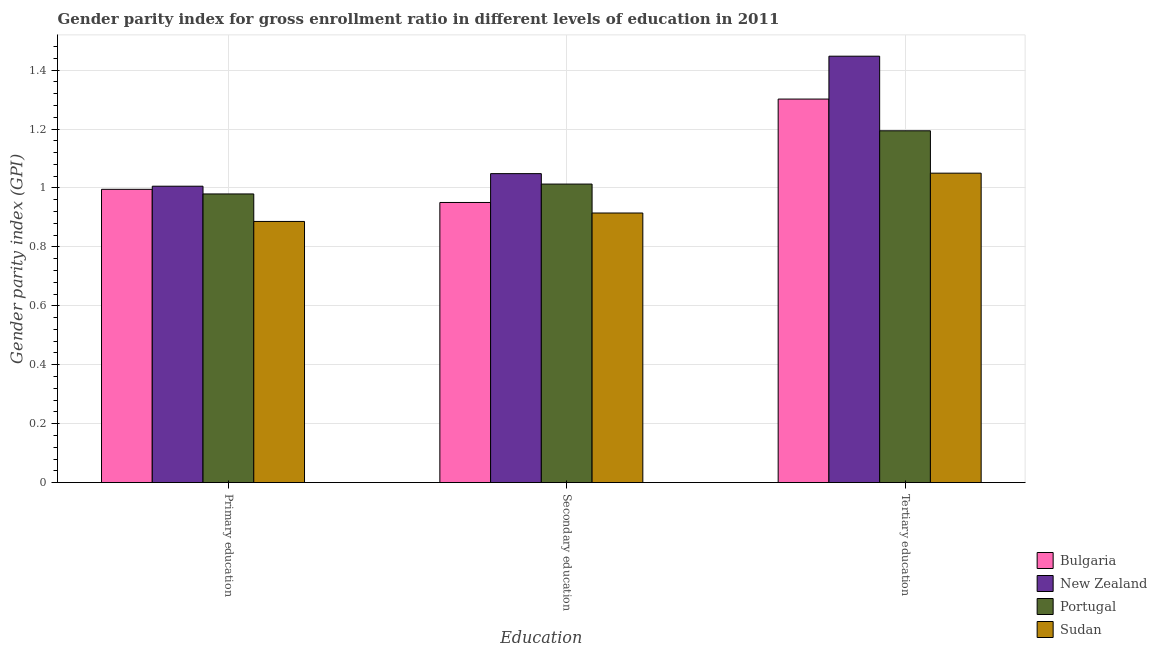How many groups of bars are there?
Your response must be concise. 3. Are the number of bars per tick equal to the number of legend labels?
Make the answer very short. Yes. What is the gender parity index in secondary education in New Zealand?
Give a very brief answer. 1.05. Across all countries, what is the maximum gender parity index in primary education?
Provide a short and direct response. 1.01. Across all countries, what is the minimum gender parity index in primary education?
Give a very brief answer. 0.89. In which country was the gender parity index in tertiary education maximum?
Your response must be concise. New Zealand. In which country was the gender parity index in tertiary education minimum?
Make the answer very short. Sudan. What is the total gender parity index in primary education in the graph?
Give a very brief answer. 3.87. What is the difference between the gender parity index in secondary education in Bulgaria and that in Portugal?
Provide a short and direct response. -0.06. What is the difference between the gender parity index in tertiary education in Bulgaria and the gender parity index in primary education in Portugal?
Keep it short and to the point. 0.32. What is the average gender parity index in tertiary education per country?
Offer a terse response. 1.25. What is the difference between the gender parity index in primary education and gender parity index in secondary education in Portugal?
Make the answer very short. -0.03. In how many countries, is the gender parity index in tertiary education greater than 0.08 ?
Offer a terse response. 4. What is the ratio of the gender parity index in tertiary education in Portugal to that in Bulgaria?
Provide a short and direct response. 0.92. Is the gender parity index in primary education in Portugal less than that in Sudan?
Your response must be concise. No. What is the difference between the highest and the second highest gender parity index in tertiary education?
Provide a short and direct response. 0.15. What is the difference between the highest and the lowest gender parity index in primary education?
Offer a very short reply. 0.12. In how many countries, is the gender parity index in tertiary education greater than the average gender parity index in tertiary education taken over all countries?
Provide a succinct answer. 2. Is the sum of the gender parity index in secondary education in Portugal and Sudan greater than the maximum gender parity index in primary education across all countries?
Offer a very short reply. Yes. What does the 2nd bar from the left in Primary education represents?
Ensure brevity in your answer.  New Zealand. What does the 2nd bar from the right in Secondary education represents?
Give a very brief answer. Portugal. Is it the case that in every country, the sum of the gender parity index in primary education and gender parity index in secondary education is greater than the gender parity index in tertiary education?
Keep it short and to the point. Yes. How many bars are there?
Ensure brevity in your answer.  12. How many countries are there in the graph?
Your answer should be very brief. 4. What is the difference between two consecutive major ticks on the Y-axis?
Provide a succinct answer. 0.2. Does the graph contain any zero values?
Make the answer very short. No. Does the graph contain grids?
Make the answer very short. Yes. How many legend labels are there?
Make the answer very short. 4. What is the title of the graph?
Give a very brief answer. Gender parity index for gross enrollment ratio in different levels of education in 2011. What is the label or title of the X-axis?
Provide a succinct answer. Education. What is the label or title of the Y-axis?
Make the answer very short. Gender parity index (GPI). What is the Gender parity index (GPI) of Bulgaria in Primary education?
Provide a succinct answer. 1. What is the Gender parity index (GPI) in New Zealand in Primary education?
Provide a succinct answer. 1.01. What is the Gender parity index (GPI) of Portugal in Primary education?
Provide a short and direct response. 0.98. What is the Gender parity index (GPI) of Sudan in Primary education?
Keep it short and to the point. 0.89. What is the Gender parity index (GPI) in Bulgaria in Secondary education?
Offer a terse response. 0.95. What is the Gender parity index (GPI) of New Zealand in Secondary education?
Provide a succinct answer. 1.05. What is the Gender parity index (GPI) of Portugal in Secondary education?
Your answer should be very brief. 1.01. What is the Gender parity index (GPI) in Sudan in Secondary education?
Offer a very short reply. 0.92. What is the Gender parity index (GPI) of Bulgaria in Tertiary education?
Give a very brief answer. 1.3. What is the Gender parity index (GPI) in New Zealand in Tertiary education?
Make the answer very short. 1.45. What is the Gender parity index (GPI) of Portugal in Tertiary education?
Your answer should be compact. 1.19. What is the Gender parity index (GPI) of Sudan in Tertiary education?
Give a very brief answer. 1.05. Across all Education, what is the maximum Gender parity index (GPI) of Bulgaria?
Ensure brevity in your answer.  1.3. Across all Education, what is the maximum Gender parity index (GPI) in New Zealand?
Offer a terse response. 1.45. Across all Education, what is the maximum Gender parity index (GPI) in Portugal?
Offer a very short reply. 1.19. Across all Education, what is the maximum Gender parity index (GPI) in Sudan?
Offer a very short reply. 1.05. Across all Education, what is the minimum Gender parity index (GPI) in Bulgaria?
Offer a very short reply. 0.95. Across all Education, what is the minimum Gender parity index (GPI) in New Zealand?
Make the answer very short. 1.01. Across all Education, what is the minimum Gender parity index (GPI) in Portugal?
Offer a terse response. 0.98. Across all Education, what is the minimum Gender parity index (GPI) of Sudan?
Provide a succinct answer. 0.89. What is the total Gender parity index (GPI) of Bulgaria in the graph?
Your answer should be very brief. 3.25. What is the total Gender parity index (GPI) of New Zealand in the graph?
Ensure brevity in your answer.  3.5. What is the total Gender parity index (GPI) in Portugal in the graph?
Your response must be concise. 3.19. What is the total Gender parity index (GPI) of Sudan in the graph?
Offer a very short reply. 2.85. What is the difference between the Gender parity index (GPI) of Bulgaria in Primary education and that in Secondary education?
Your answer should be very brief. 0.04. What is the difference between the Gender parity index (GPI) of New Zealand in Primary education and that in Secondary education?
Provide a succinct answer. -0.04. What is the difference between the Gender parity index (GPI) in Portugal in Primary education and that in Secondary education?
Provide a succinct answer. -0.03. What is the difference between the Gender parity index (GPI) of Sudan in Primary education and that in Secondary education?
Make the answer very short. -0.03. What is the difference between the Gender parity index (GPI) of Bulgaria in Primary education and that in Tertiary education?
Offer a very short reply. -0.31. What is the difference between the Gender parity index (GPI) of New Zealand in Primary education and that in Tertiary education?
Make the answer very short. -0.44. What is the difference between the Gender parity index (GPI) of Portugal in Primary education and that in Tertiary education?
Your answer should be compact. -0.21. What is the difference between the Gender parity index (GPI) of Sudan in Primary education and that in Tertiary education?
Ensure brevity in your answer.  -0.16. What is the difference between the Gender parity index (GPI) of Bulgaria in Secondary education and that in Tertiary education?
Make the answer very short. -0.35. What is the difference between the Gender parity index (GPI) of New Zealand in Secondary education and that in Tertiary education?
Provide a succinct answer. -0.4. What is the difference between the Gender parity index (GPI) in Portugal in Secondary education and that in Tertiary education?
Offer a terse response. -0.18. What is the difference between the Gender parity index (GPI) of Sudan in Secondary education and that in Tertiary education?
Provide a short and direct response. -0.14. What is the difference between the Gender parity index (GPI) in Bulgaria in Primary education and the Gender parity index (GPI) in New Zealand in Secondary education?
Your response must be concise. -0.05. What is the difference between the Gender parity index (GPI) of Bulgaria in Primary education and the Gender parity index (GPI) of Portugal in Secondary education?
Provide a succinct answer. -0.02. What is the difference between the Gender parity index (GPI) of Bulgaria in Primary education and the Gender parity index (GPI) of Sudan in Secondary education?
Provide a succinct answer. 0.08. What is the difference between the Gender parity index (GPI) in New Zealand in Primary education and the Gender parity index (GPI) in Portugal in Secondary education?
Give a very brief answer. -0.01. What is the difference between the Gender parity index (GPI) of New Zealand in Primary education and the Gender parity index (GPI) of Sudan in Secondary education?
Provide a succinct answer. 0.09. What is the difference between the Gender parity index (GPI) in Portugal in Primary education and the Gender parity index (GPI) in Sudan in Secondary education?
Your response must be concise. 0.06. What is the difference between the Gender parity index (GPI) of Bulgaria in Primary education and the Gender parity index (GPI) of New Zealand in Tertiary education?
Your answer should be compact. -0.45. What is the difference between the Gender parity index (GPI) in Bulgaria in Primary education and the Gender parity index (GPI) in Portugal in Tertiary education?
Keep it short and to the point. -0.2. What is the difference between the Gender parity index (GPI) of Bulgaria in Primary education and the Gender parity index (GPI) of Sudan in Tertiary education?
Make the answer very short. -0.05. What is the difference between the Gender parity index (GPI) of New Zealand in Primary education and the Gender parity index (GPI) of Portugal in Tertiary education?
Offer a terse response. -0.19. What is the difference between the Gender parity index (GPI) of New Zealand in Primary education and the Gender parity index (GPI) of Sudan in Tertiary education?
Offer a very short reply. -0.04. What is the difference between the Gender parity index (GPI) in Portugal in Primary education and the Gender parity index (GPI) in Sudan in Tertiary education?
Your answer should be very brief. -0.07. What is the difference between the Gender parity index (GPI) of Bulgaria in Secondary education and the Gender parity index (GPI) of New Zealand in Tertiary education?
Offer a terse response. -0.5. What is the difference between the Gender parity index (GPI) of Bulgaria in Secondary education and the Gender parity index (GPI) of Portugal in Tertiary education?
Ensure brevity in your answer.  -0.24. What is the difference between the Gender parity index (GPI) in Bulgaria in Secondary education and the Gender parity index (GPI) in Sudan in Tertiary education?
Your response must be concise. -0.1. What is the difference between the Gender parity index (GPI) in New Zealand in Secondary education and the Gender parity index (GPI) in Portugal in Tertiary education?
Provide a succinct answer. -0.15. What is the difference between the Gender parity index (GPI) of New Zealand in Secondary education and the Gender parity index (GPI) of Sudan in Tertiary education?
Ensure brevity in your answer.  -0. What is the difference between the Gender parity index (GPI) in Portugal in Secondary education and the Gender parity index (GPI) in Sudan in Tertiary education?
Make the answer very short. -0.04. What is the average Gender parity index (GPI) in Bulgaria per Education?
Ensure brevity in your answer.  1.08. What is the average Gender parity index (GPI) of New Zealand per Education?
Provide a succinct answer. 1.17. What is the average Gender parity index (GPI) in Portugal per Education?
Provide a succinct answer. 1.06. What is the average Gender parity index (GPI) of Sudan per Education?
Provide a short and direct response. 0.95. What is the difference between the Gender parity index (GPI) in Bulgaria and Gender parity index (GPI) in New Zealand in Primary education?
Offer a very short reply. -0.01. What is the difference between the Gender parity index (GPI) of Bulgaria and Gender parity index (GPI) of Portugal in Primary education?
Provide a succinct answer. 0.02. What is the difference between the Gender parity index (GPI) in Bulgaria and Gender parity index (GPI) in Sudan in Primary education?
Your answer should be compact. 0.11. What is the difference between the Gender parity index (GPI) of New Zealand and Gender parity index (GPI) of Portugal in Primary education?
Offer a terse response. 0.03. What is the difference between the Gender parity index (GPI) of New Zealand and Gender parity index (GPI) of Sudan in Primary education?
Provide a short and direct response. 0.12. What is the difference between the Gender parity index (GPI) of Portugal and Gender parity index (GPI) of Sudan in Primary education?
Your answer should be compact. 0.09. What is the difference between the Gender parity index (GPI) in Bulgaria and Gender parity index (GPI) in New Zealand in Secondary education?
Your answer should be very brief. -0.1. What is the difference between the Gender parity index (GPI) of Bulgaria and Gender parity index (GPI) of Portugal in Secondary education?
Ensure brevity in your answer.  -0.06. What is the difference between the Gender parity index (GPI) of Bulgaria and Gender parity index (GPI) of Sudan in Secondary education?
Offer a terse response. 0.04. What is the difference between the Gender parity index (GPI) of New Zealand and Gender parity index (GPI) of Portugal in Secondary education?
Provide a succinct answer. 0.04. What is the difference between the Gender parity index (GPI) of New Zealand and Gender parity index (GPI) of Sudan in Secondary education?
Ensure brevity in your answer.  0.13. What is the difference between the Gender parity index (GPI) in Portugal and Gender parity index (GPI) in Sudan in Secondary education?
Provide a succinct answer. 0.1. What is the difference between the Gender parity index (GPI) of Bulgaria and Gender parity index (GPI) of New Zealand in Tertiary education?
Keep it short and to the point. -0.15. What is the difference between the Gender parity index (GPI) in Bulgaria and Gender parity index (GPI) in Portugal in Tertiary education?
Give a very brief answer. 0.11. What is the difference between the Gender parity index (GPI) in Bulgaria and Gender parity index (GPI) in Sudan in Tertiary education?
Give a very brief answer. 0.25. What is the difference between the Gender parity index (GPI) of New Zealand and Gender parity index (GPI) of Portugal in Tertiary education?
Keep it short and to the point. 0.25. What is the difference between the Gender parity index (GPI) in New Zealand and Gender parity index (GPI) in Sudan in Tertiary education?
Your answer should be very brief. 0.4. What is the difference between the Gender parity index (GPI) of Portugal and Gender parity index (GPI) of Sudan in Tertiary education?
Offer a very short reply. 0.14. What is the ratio of the Gender parity index (GPI) in Bulgaria in Primary education to that in Secondary education?
Offer a terse response. 1.05. What is the ratio of the Gender parity index (GPI) of New Zealand in Primary education to that in Secondary education?
Ensure brevity in your answer.  0.96. What is the ratio of the Gender parity index (GPI) of Portugal in Primary education to that in Secondary education?
Ensure brevity in your answer.  0.97. What is the ratio of the Gender parity index (GPI) in Sudan in Primary education to that in Secondary education?
Ensure brevity in your answer.  0.97. What is the ratio of the Gender parity index (GPI) in Bulgaria in Primary education to that in Tertiary education?
Give a very brief answer. 0.76. What is the ratio of the Gender parity index (GPI) of New Zealand in Primary education to that in Tertiary education?
Offer a terse response. 0.7. What is the ratio of the Gender parity index (GPI) of Portugal in Primary education to that in Tertiary education?
Give a very brief answer. 0.82. What is the ratio of the Gender parity index (GPI) in Sudan in Primary education to that in Tertiary education?
Give a very brief answer. 0.84. What is the ratio of the Gender parity index (GPI) in Bulgaria in Secondary education to that in Tertiary education?
Keep it short and to the point. 0.73. What is the ratio of the Gender parity index (GPI) of New Zealand in Secondary education to that in Tertiary education?
Your response must be concise. 0.72. What is the ratio of the Gender parity index (GPI) of Portugal in Secondary education to that in Tertiary education?
Your answer should be compact. 0.85. What is the ratio of the Gender parity index (GPI) in Sudan in Secondary education to that in Tertiary education?
Make the answer very short. 0.87. What is the difference between the highest and the second highest Gender parity index (GPI) in Bulgaria?
Offer a terse response. 0.31. What is the difference between the highest and the second highest Gender parity index (GPI) in New Zealand?
Your answer should be very brief. 0.4. What is the difference between the highest and the second highest Gender parity index (GPI) in Portugal?
Offer a terse response. 0.18. What is the difference between the highest and the second highest Gender parity index (GPI) of Sudan?
Provide a short and direct response. 0.14. What is the difference between the highest and the lowest Gender parity index (GPI) in Bulgaria?
Provide a short and direct response. 0.35. What is the difference between the highest and the lowest Gender parity index (GPI) in New Zealand?
Your answer should be very brief. 0.44. What is the difference between the highest and the lowest Gender parity index (GPI) of Portugal?
Your response must be concise. 0.21. What is the difference between the highest and the lowest Gender parity index (GPI) of Sudan?
Your answer should be very brief. 0.16. 